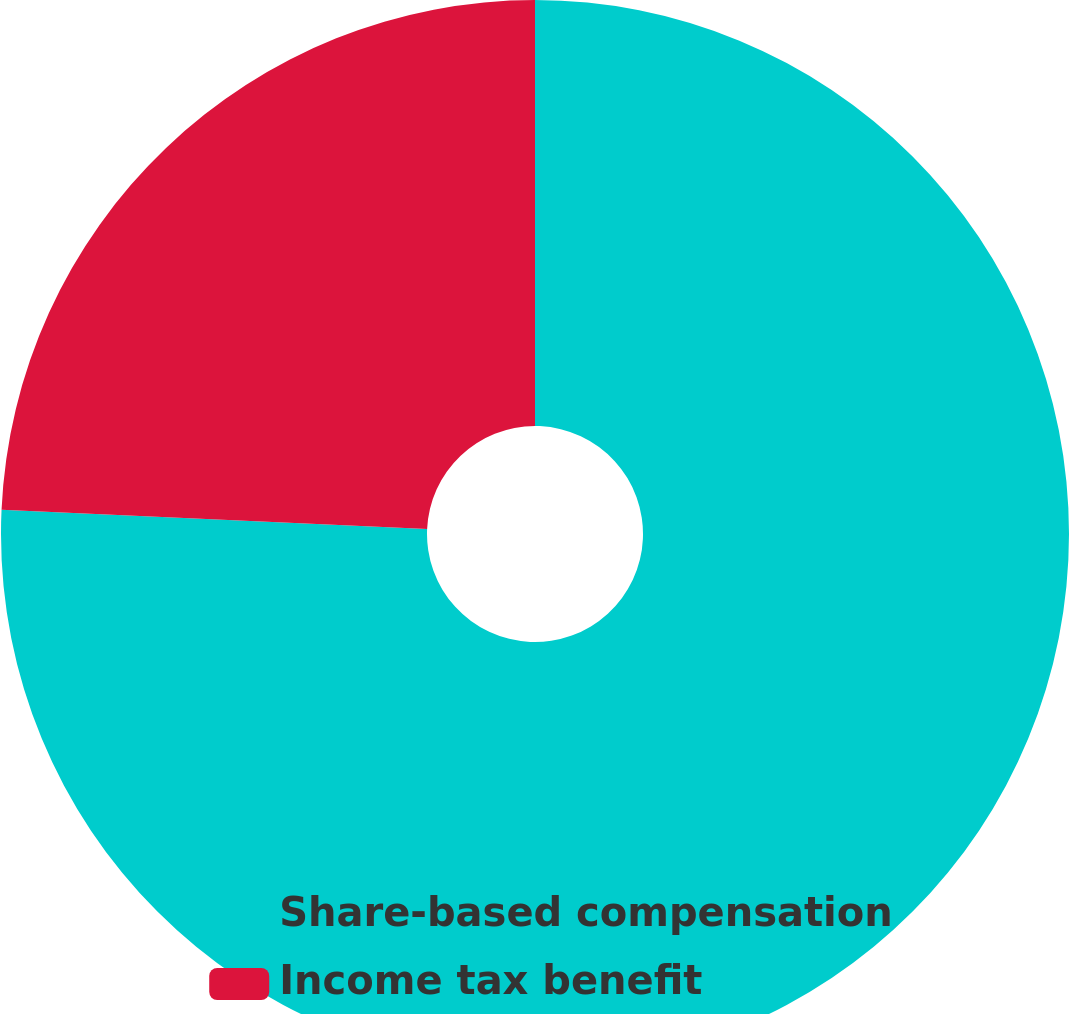<chart> <loc_0><loc_0><loc_500><loc_500><pie_chart><fcel>Share-based compensation<fcel>Income tax benefit<nl><fcel>75.72%<fcel>24.28%<nl></chart> 